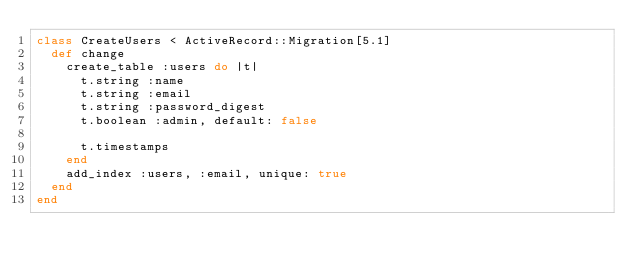Convert code to text. <code><loc_0><loc_0><loc_500><loc_500><_Ruby_>class CreateUsers < ActiveRecord::Migration[5.1]
  def change
    create_table :users do |t|
      t.string :name
      t.string :email
      t.string :password_digest
      t.boolean :admin, default: false

      t.timestamps
    end
    add_index :users, :email, unique: true
  end
end
</code> 